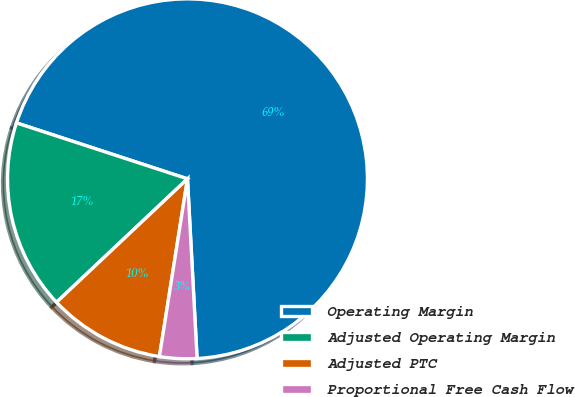Convert chart to OTSL. <chart><loc_0><loc_0><loc_500><loc_500><pie_chart><fcel>Operating Margin<fcel>Adjusted Operating Margin<fcel>Adjusted PTC<fcel>Proportional Free Cash Flow<nl><fcel>69.12%<fcel>17.06%<fcel>10.48%<fcel>3.34%<nl></chart> 